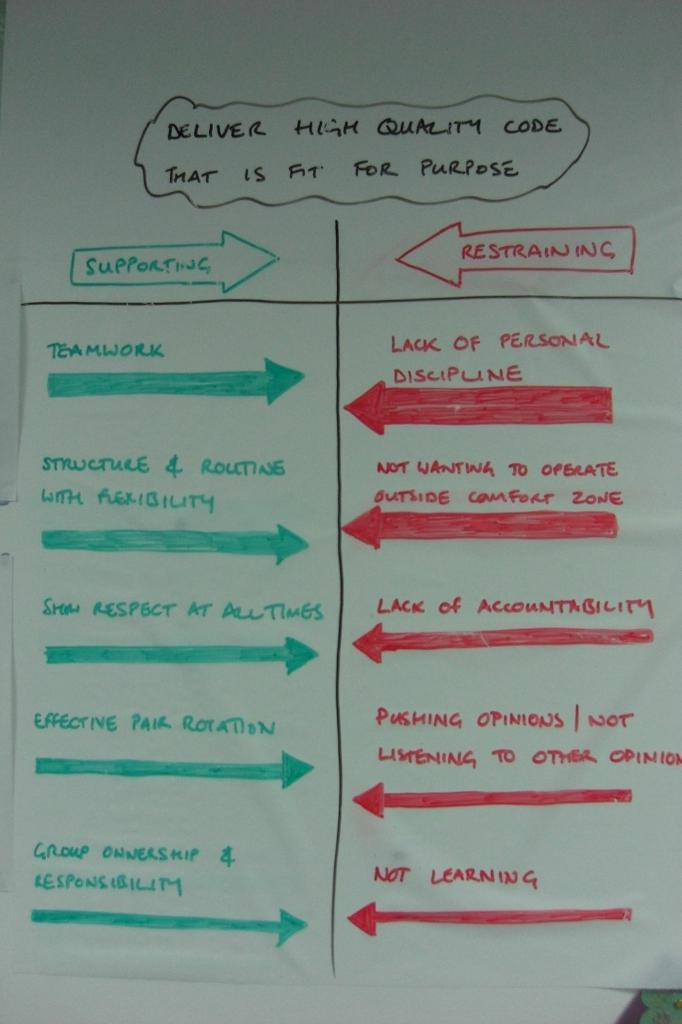<image>
Give a short and clear explanation of the subsequent image. Supporting and restraining arguments for high quality code is seen on a noteboard. 